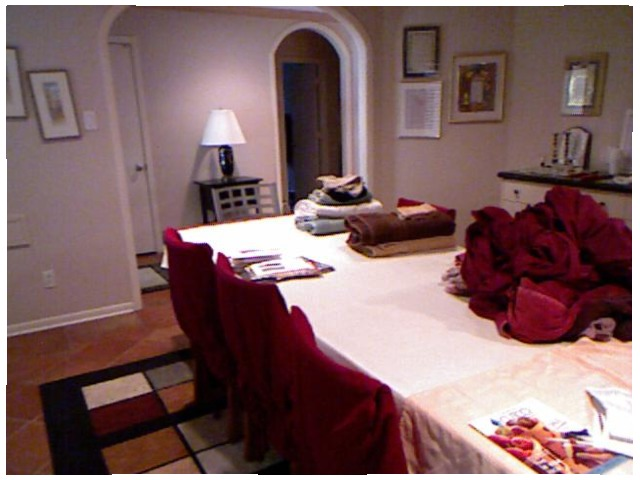<image>
Is there a table lamp on the side table? Yes. Looking at the image, I can see the table lamp is positioned on top of the side table, with the side table providing support. Where is the towels in relation to the table? Is it on the table? Yes. Looking at the image, I can see the towels is positioned on top of the table, with the table providing support. 